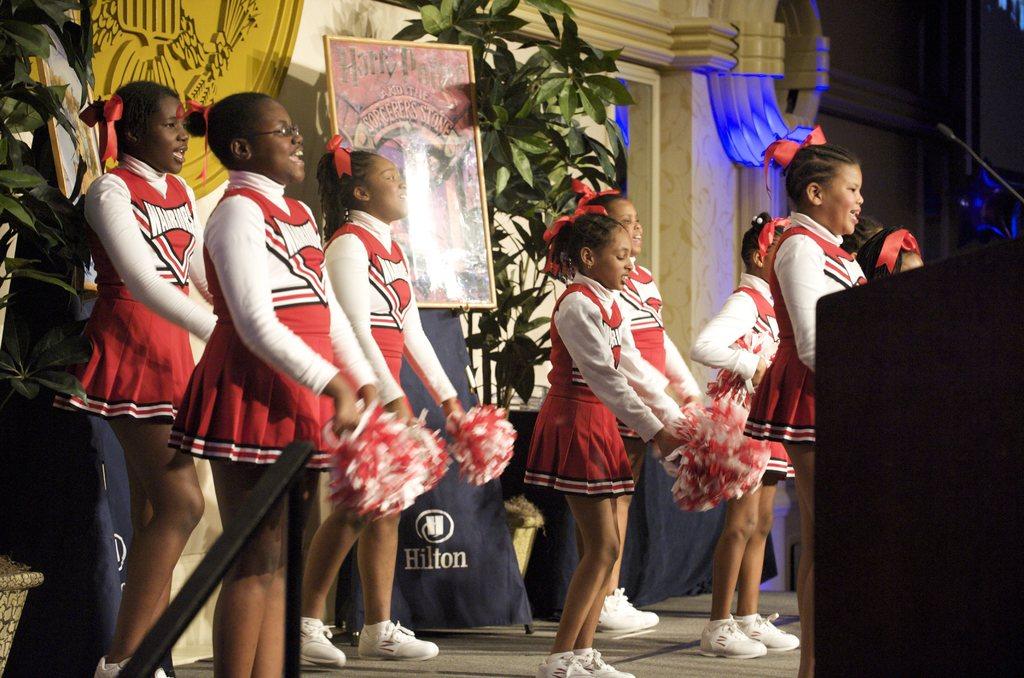Which hotel are they at?
Offer a very short reply. Hilton. 